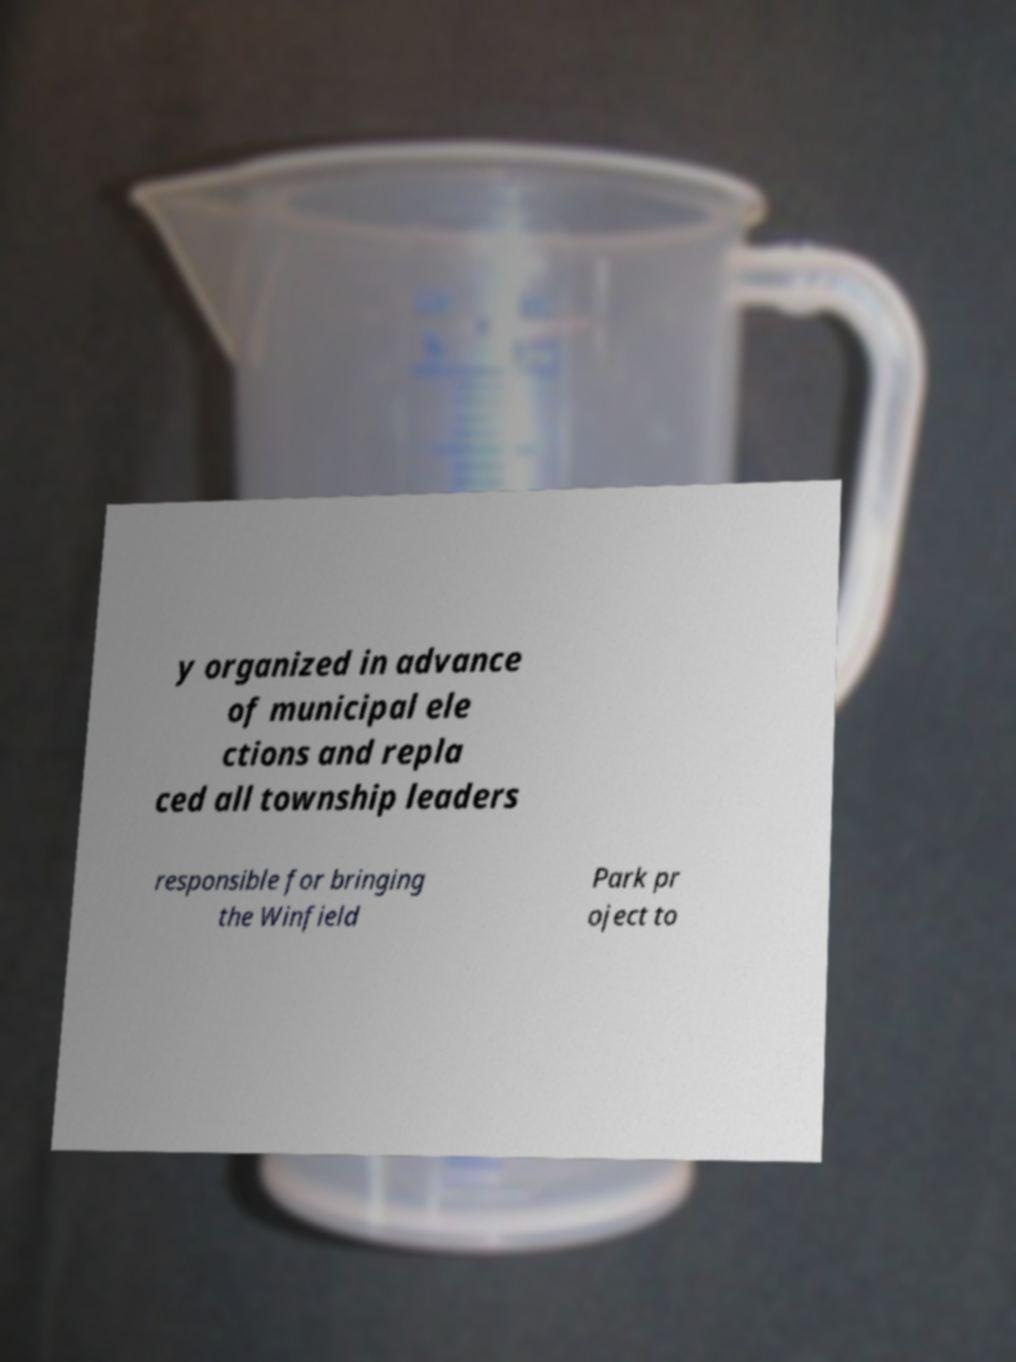Please read and relay the text visible in this image. What does it say? y organized in advance of municipal ele ctions and repla ced all township leaders responsible for bringing the Winfield Park pr oject to 